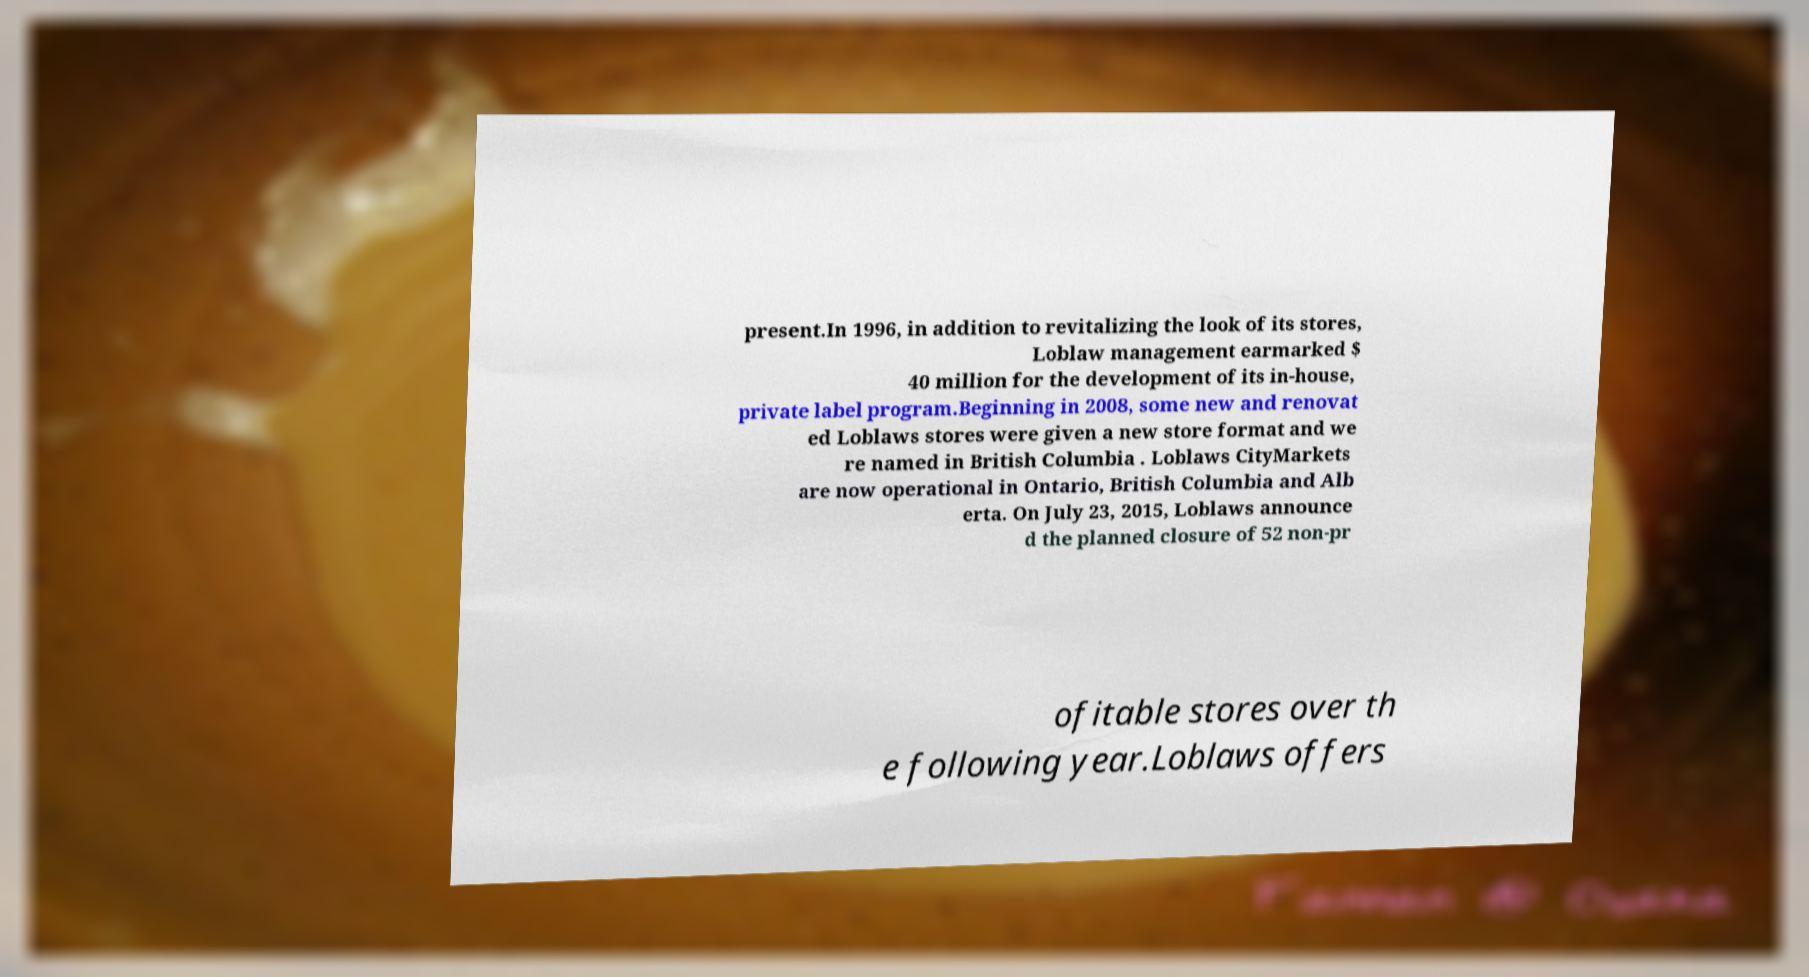Please read and relay the text visible in this image. What does it say? present.In 1996, in addition to revitalizing the look of its stores, Loblaw management earmarked $ 40 million for the development of its in-house, private label program.Beginning in 2008, some new and renovat ed Loblaws stores were given a new store format and we re named in British Columbia . Loblaws CityMarkets are now operational in Ontario, British Columbia and Alb erta. On July 23, 2015, Loblaws announce d the planned closure of 52 non-pr ofitable stores over th e following year.Loblaws offers 